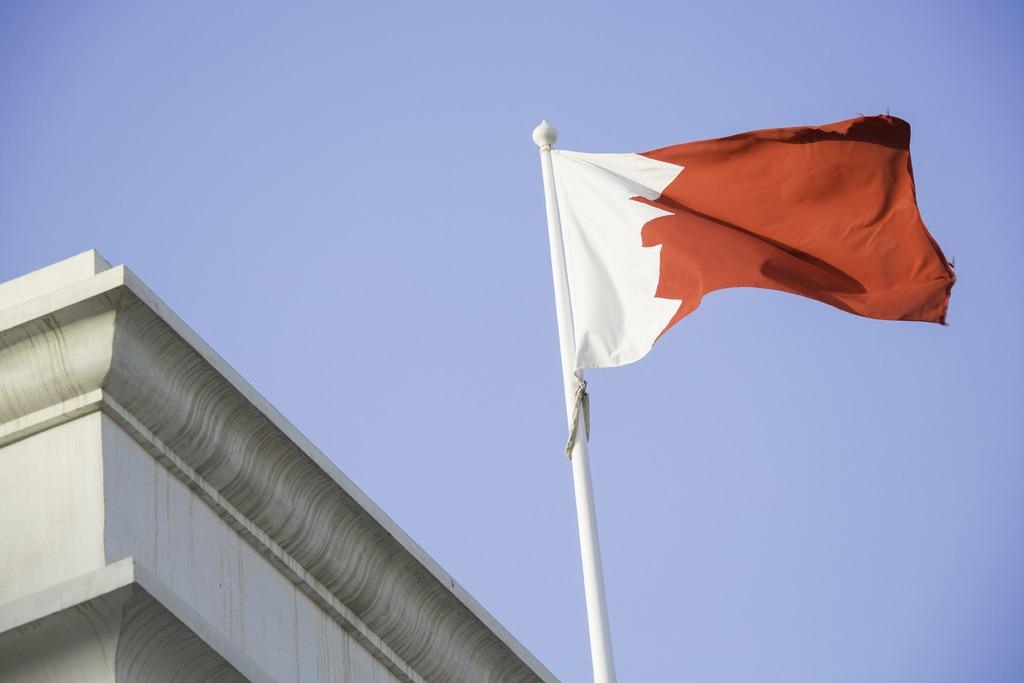What is present on the right side of the image? There is a flag in the image, and it is on the right side. What colors are featured on the flag? The flag is white and red in color. What can be seen on the left side of the image? There appears to be a building fencing on the left side of the image. Is there a pickle on the flag in the image? No, there is no pickle present on the flag in the image. Can you identify the writer of the flag in the image? There is no writer associated with the flag in the image. 